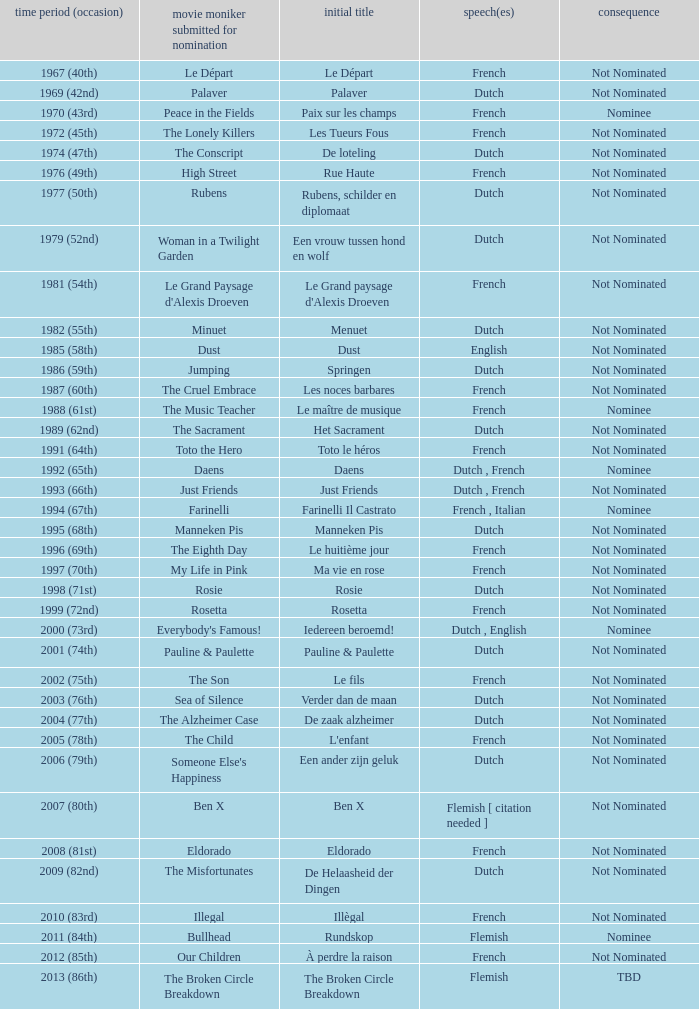What is the language of the film Rosie? Dutch. 